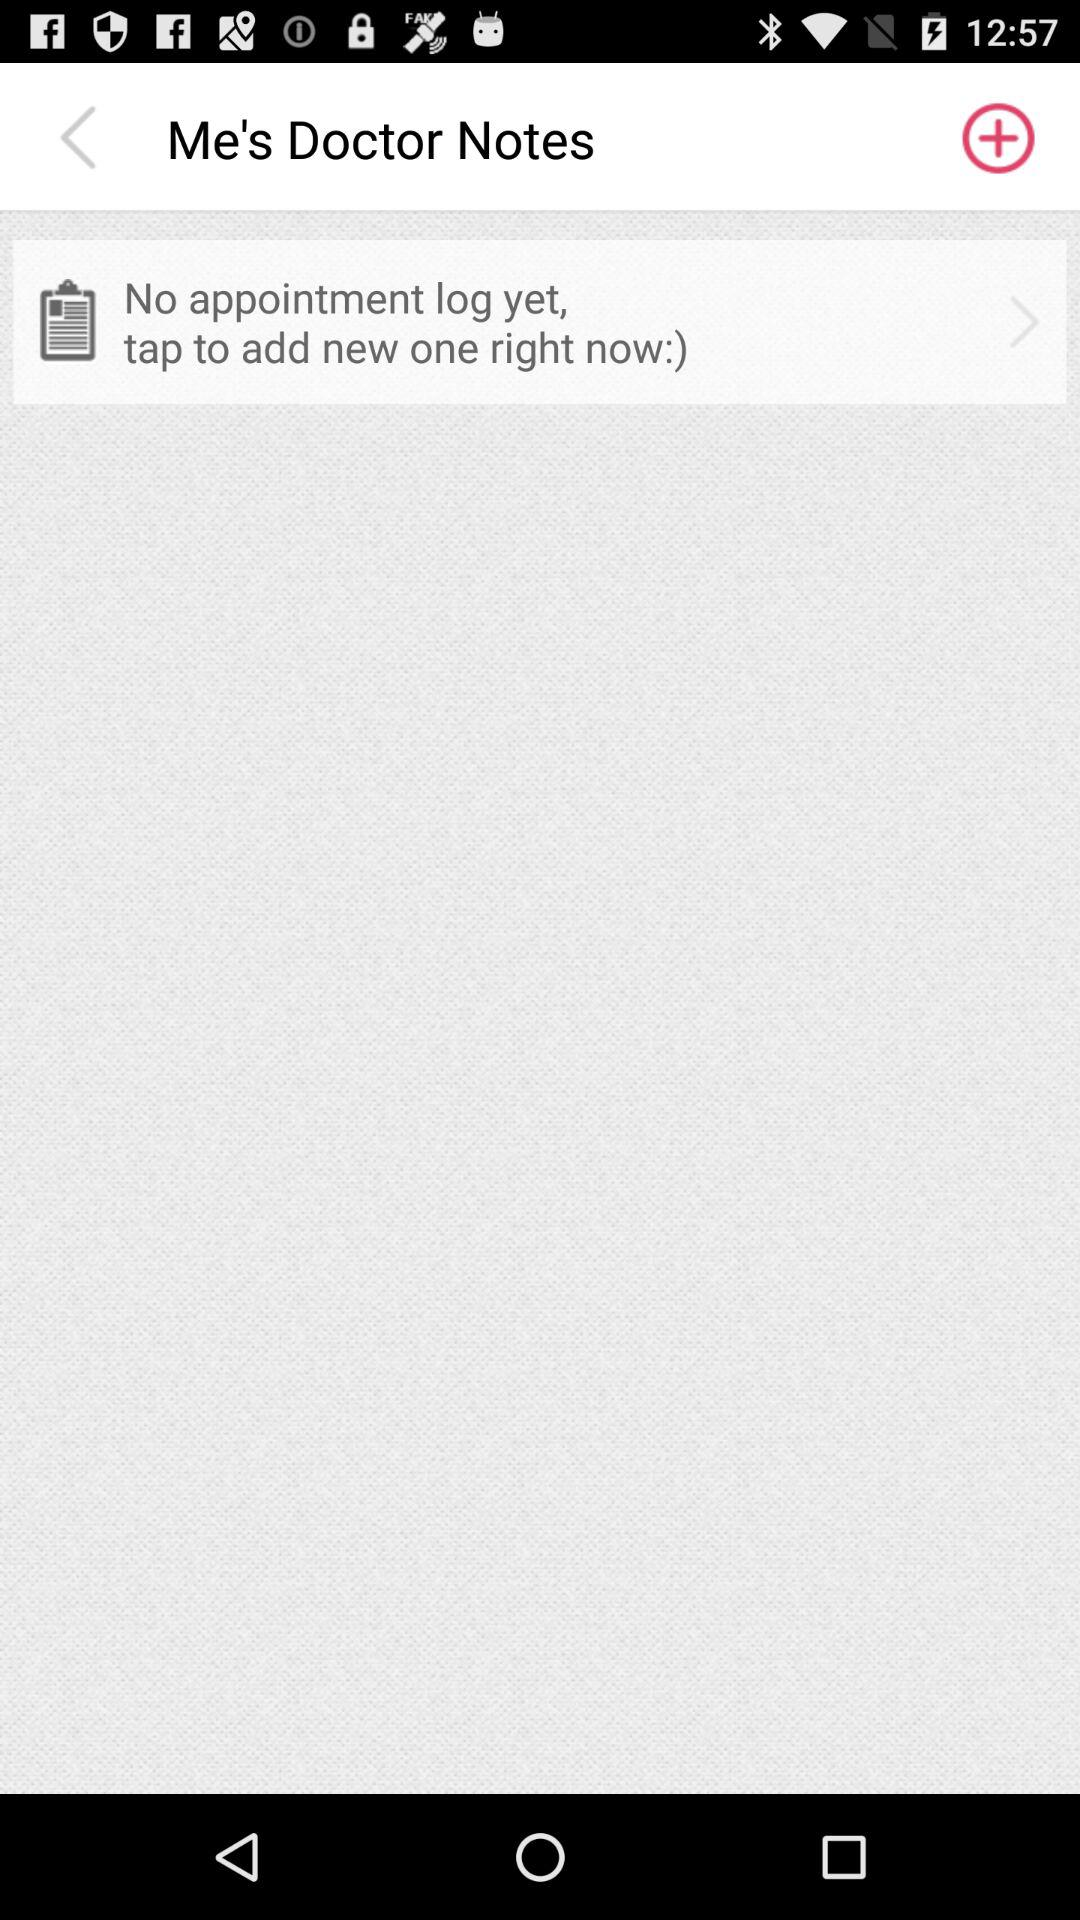What is the note name? The note name is "Me's Doctor Notes". 